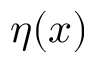Convert formula to latex. <formula><loc_0><loc_0><loc_500><loc_500>\eta ( x )</formula> 